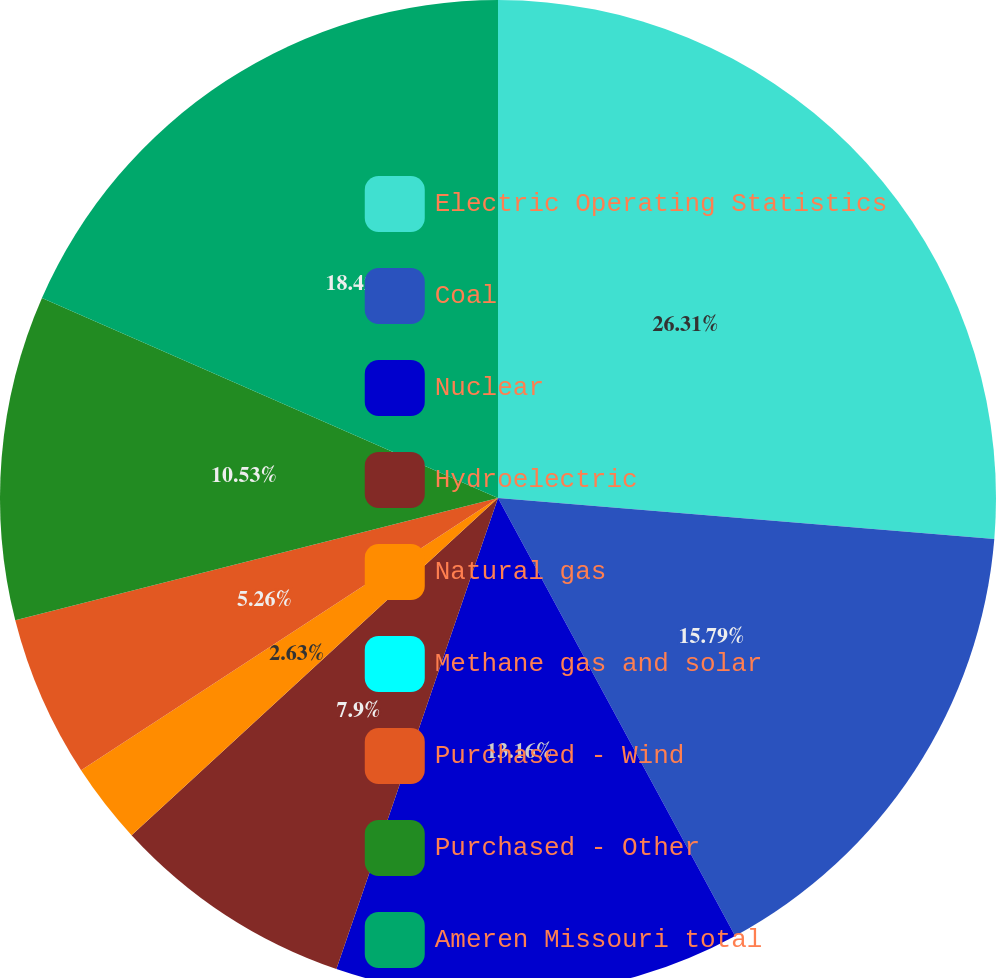Convert chart. <chart><loc_0><loc_0><loc_500><loc_500><pie_chart><fcel>Electric Operating Statistics<fcel>Coal<fcel>Nuclear<fcel>Hydroelectric<fcel>Natural gas<fcel>Methane gas and solar<fcel>Purchased - Wind<fcel>Purchased - Other<fcel>Ameren Missouri total<nl><fcel>26.31%<fcel>15.79%<fcel>13.16%<fcel>7.9%<fcel>2.63%<fcel>0.0%<fcel>5.26%<fcel>10.53%<fcel>18.42%<nl></chart> 